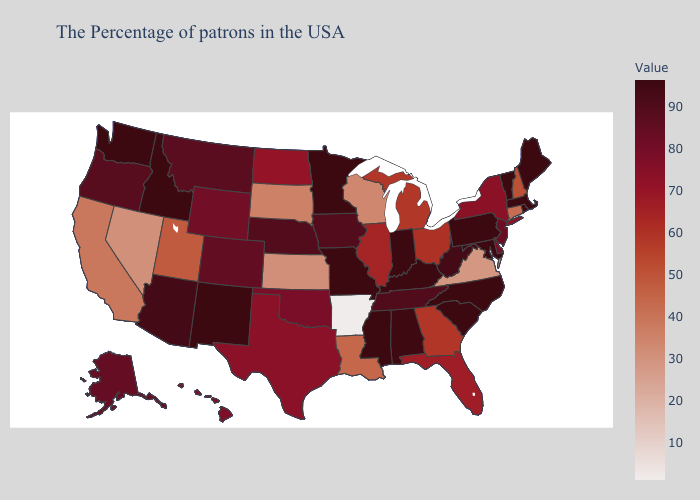Does Georgia have a higher value than Hawaii?
Concise answer only. No. Among the states that border Idaho , does Utah have the highest value?
Short answer required. No. Does Nebraska have the highest value in the MidWest?
Short answer required. No. Is the legend a continuous bar?
Give a very brief answer. Yes. Among the states that border Connecticut , does New York have the lowest value?
Write a very short answer. Yes. Among the states that border Pennsylvania , which have the highest value?
Be succinct. Maryland. Which states have the highest value in the USA?
Keep it brief. Maine, Massachusetts, Rhode Island, Vermont, Maryland, Pennsylvania, North Carolina, South Carolina, Kentucky, Indiana, Mississippi, Missouri, Minnesota, New Mexico, Idaho, Washington. 